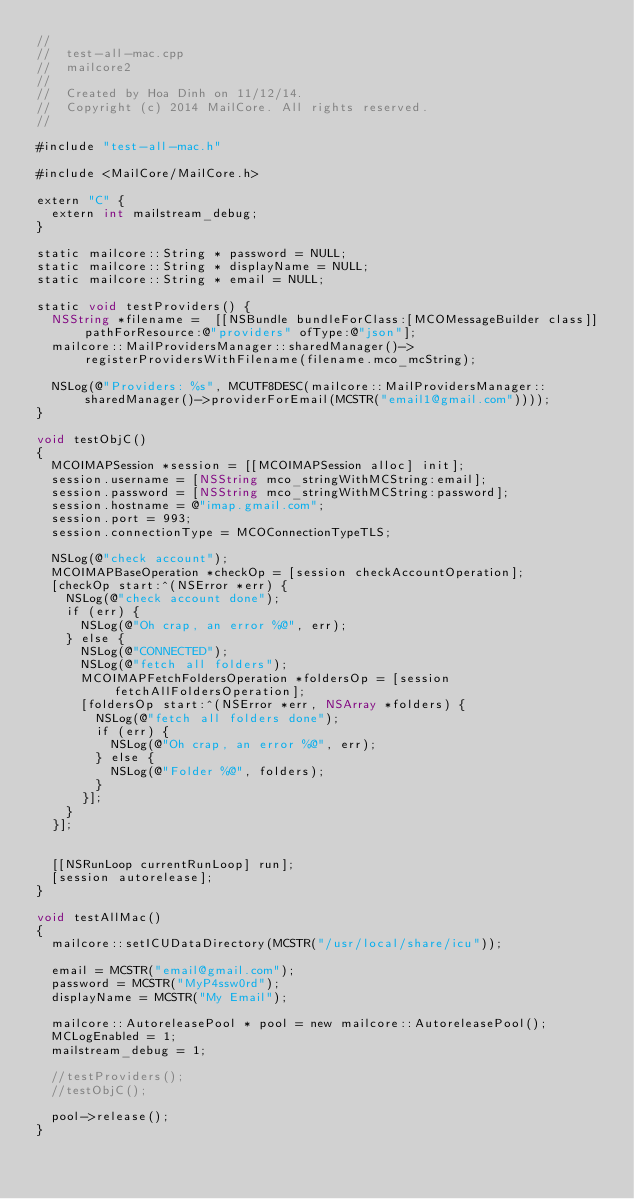Convert code to text. <code><loc_0><loc_0><loc_500><loc_500><_ObjectiveC_>//
//  test-all-mac.cpp
//  mailcore2
//
//  Created by Hoa Dinh on 11/12/14.
//  Copyright (c) 2014 MailCore. All rights reserved.
//

#include "test-all-mac.h"

#include <MailCore/MailCore.h>

extern "C" {
  extern int mailstream_debug;
}

static mailcore::String * password = NULL;
static mailcore::String * displayName = NULL;
static mailcore::String * email = NULL;

static void testProviders() {
  NSString *filename =  [[NSBundle bundleForClass:[MCOMessageBuilder class]] pathForResource:@"providers" ofType:@"json"];
  mailcore::MailProvidersManager::sharedManager()->registerProvidersWithFilename(filename.mco_mcString);
  
  NSLog(@"Providers: %s", MCUTF8DESC(mailcore::MailProvidersManager::sharedManager()->providerForEmail(MCSTR("email1@gmail.com"))));
}

void testObjC()
{
  MCOIMAPSession *session = [[MCOIMAPSession alloc] init];
  session.username = [NSString mco_stringWithMCString:email];
  session.password = [NSString mco_stringWithMCString:password];
  session.hostname = @"imap.gmail.com";
  session.port = 993;
  session.connectionType = MCOConnectionTypeTLS;
  
  NSLog(@"check account");
  MCOIMAPBaseOperation *checkOp = [session checkAccountOperation];
  [checkOp start:^(NSError *err) {
    NSLog(@"check account done");
    if (err) {
      NSLog(@"Oh crap, an error %@", err);
    } else {
      NSLog(@"CONNECTED");
      NSLog(@"fetch all folders");
      MCOIMAPFetchFoldersOperation *foldersOp = [session fetchAllFoldersOperation];
      [foldersOp start:^(NSError *err, NSArray *folders) {
        NSLog(@"fetch all folders done");
        if (err) {
          NSLog(@"Oh crap, an error %@", err);
        } else {
          NSLog(@"Folder %@", folders);
        }
      }];
    }
  }];
  
  
  [[NSRunLoop currentRunLoop] run];
  [session autorelease];
}

void testAllMac()
{
  mailcore::setICUDataDirectory(MCSTR("/usr/local/share/icu"));
  
  email = MCSTR("email@gmail.com");
  password = MCSTR("MyP4ssw0rd");
  displayName = MCSTR("My Email");
  
  mailcore::AutoreleasePool * pool = new mailcore::AutoreleasePool();
  MCLogEnabled = 1;
  mailstream_debug = 1;
  
  //testProviders();
  //testObjC();
  
  pool->release();
}
</code> 